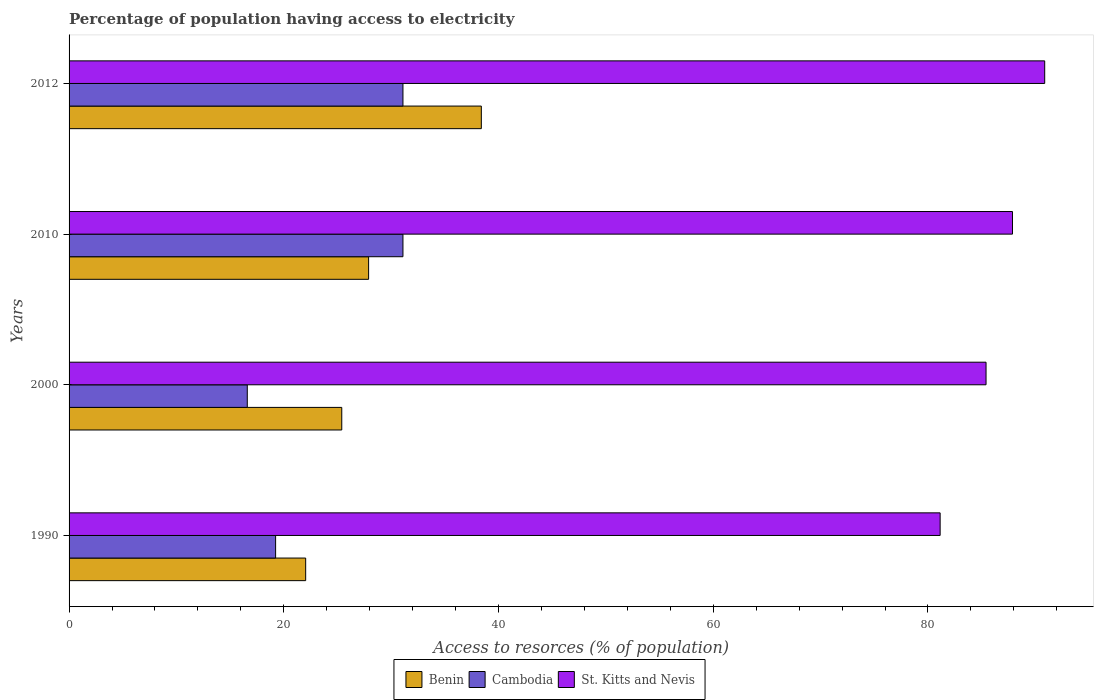How many different coloured bars are there?
Your answer should be very brief. 3. Are the number of bars per tick equal to the number of legend labels?
Give a very brief answer. Yes. Are the number of bars on each tick of the Y-axis equal?
Offer a terse response. Yes. How many bars are there on the 3rd tick from the top?
Make the answer very short. 3. How many bars are there on the 3rd tick from the bottom?
Make the answer very short. 3. In how many cases, is the number of bars for a given year not equal to the number of legend labels?
Offer a terse response. 0. What is the percentage of population having access to electricity in Benin in 2000?
Give a very brief answer. 25.4. Across all years, what is the maximum percentage of population having access to electricity in Cambodia?
Your answer should be very brief. 31.1. What is the total percentage of population having access to electricity in St. Kitts and Nevis in the graph?
Your answer should be compact. 345.3. What is the difference between the percentage of population having access to electricity in Cambodia in 1990 and that in 2000?
Ensure brevity in your answer.  2.64. What is the difference between the percentage of population having access to electricity in St. Kitts and Nevis in 2000 and the percentage of population having access to electricity in Cambodia in 2012?
Make the answer very short. 54.31. What is the average percentage of population having access to electricity in Cambodia per year?
Give a very brief answer. 24.51. In the year 2012, what is the difference between the percentage of population having access to electricity in St. Kitts and Nevis and percentage of population having access to electricity in Cambodia?
Your answer should be compact. 59.78. In how many years, is the percentage of population having access to electricity in St. Kitts and Nevis greater than 24 %?
Provide a succinct answer. 4. What is the ratio of the percentage of population having access to electricity in St. Kitts and Nevis in 2000 to that in 2012?
Make the answer very short. 0.94. Is the percentage of population having access to electricity in Benin in 2000 less than that in 2010?
Provide a short and direct response. Yes. What is the difference between the highest and the second highest percentage of population having access to electricity in St. Kitts and Nevis?
Provide a short and direct response. 3. What is the difference between the highest and the lowest percentage of population having access to electricity in St. Kitts and Nevis?
Your response must be concise. 9.74. Is the sum of the percentage of population having access to electricity in St. Kitts and Nevis in 1990 and 2012 greater than the maximum percentage of population having access to electricity in Cambodia across all years?
Provide a short and direct response. Yes. What does the 3rd bar from the top in 2010 represents?
Give a very brief answer. Benin. What does the 1st bar from the bottom in 1990 represents?
Offer a terse response. Benin. Is it the case that in every year, the sum of the percentage of population having access to electricity in Cambodia and percentage of population having access to electricity in Benin is greater than the percentage of population having access to electricity in St. Kitts and Nevis?
Give a very brief answer. No. What is the difference between two consecutive major ticks on the X-axis?
Provide a succinct answer. 20. Are the values on the major ticks of X-axis written in scientific E-notation?
Your answer should be very brief. No. How are the legend labels stacked?
Keep it short and to the point. Horizontal. What is the title of the graph?
Offer a very short reply. Percentage of population having access to electricity. What is the label or title of the X-axis?
Keep it short and to the point. Access to resorces (% of population). What is the Access to resorces (% of population) of Benin in 1990?
Provide a short and direct response. 22.04. What is the Access to resorces (% of population) in Cambodia in 1990?
Your response must be concise. 19.24. What is the Access to resorces (% of population) in St. Kitts and Nevis in 1990?
Provide a succinct answer. 81.14. What is the Access to resorces (% of population) in Benin in 2000?
Make the answer very short. 25.4. What is the Access to resorces (% of population) of Cambodia in 2000?
Your answer should be very brief. 16.6. What is the Access to resorces (% of population) of St. Kitts and Nevis in 2000?
Provide a short and direct response. 85.41. What is the Access to resorces (% of population) in Benin in 2010?
Offer a very short reply. 27.9. What is the Access to resorces (% of population) of Cambodia in 2010?
Your response must be concise. 31.1. What is the Access to resorces (% of population) of St. Kitts and Nevis in 2010?
Your response must be concise. 87.87. What is the Access to resorces (% of population) of Benin in 2012?
Ensure brevity in your answer.  38.4. What is the Access to resorces (% of population) of Cambodia in 2012?
Your answer should be compact. 31.1. What is the Access to resorces (% of population) of St. Kitts and Nevis in 2012?
Your answer should be very brief. 90.88. Across all years, what is the maximum Access to resorces (% of population) in Benin?
Ensure brevity in your answer.  38.4. Across all years, what is the maximum Access to resorces (% of population) in Cambodia?
Your response must be concise. 31.1. Across all years, what is the maximum Access to resorces (% of population) of St. Kitts and Nevis?
Give a very brief answer. 90.88. Across all years, what is the minimum Access to resorces (% of population) of Benin?
Give a very brief answer. 22.04. Across all years, what is the minimum Access to resorces (% of population) of Cambodia?
Offer a very short reply. 16.6. Across all years, what is the minimum Access to resorces (% of population) in St. Kitts and Nevis?
Offer a terse response. 81.14. What is the total Access to resorces (% of population) in Benin in the graph?
Give a very brief answer. 113.74. What is the total Access to resorces (% of population) of Cambodia in the graph?
Keep it short and to the point. 98.04. What is the total Access to resorces (% of population) of St. Kitts and Nevis in the graph?
Provide a succinct answer. 345.3. What is the difference between the Access to resorces (% of population) of Benin in 1990 and that in 2000?
Your answer should be very brief. -3.36. What is the difference between the Access to resorces (% of population) of Cambodia in 1990 and that in 2000?
Provide a short and direct response. 2.64. What is the difference between the Access to resorces (% of population) of St. Kitts and Nevis in 1990 and that in 2000?
Keep it short and to the point. -4.28. What is the difference between the Access to resorces (% of population) of Benin in 1990 and that in 2010?
Offer a very short reply. -5.86. What is the difference between the Access to resorces (% of population) in Cambodia in 1990 and that in 2010?
Your answer should be very brief. -11.86. What is the difference between the Access to resorces (% of population) of St. Kitts and Nevis in 1990 and that in 2010?
Your response must be concise. -6.74. What is the difference between the Access to resorces (% of population) of Benin in 1990 and that in 2012?
Keep it short and to the point. -16.36. What is the difference between the Access to resorces (% of population) of Cambodia in 1990 and that in 2012?
Make the answer very short. -11.86. What is the difference between the Access to resorces (% of population) of St. Kitts and Nevis in 1990 and that in 2012?
Make the answer very short. -9.74. What is the difference between the Access to resorces (% of population) in St. Kitts and Nevis in 2000 and that in 2010?
Offer a terse response. -2.46. What is the difference between the Access to resorces (% of population) in St. Kitts and Nevis in 2000 and that in 2012?
Offer a terse response. -5.46. What is the difference between the Access to resorces (% of population) of Benin in 2010 and that in 2012?
Make the answer very short. -10.5. What is the difference between the Access to resorces (% of population) in Cambodia in 2010 and that in 2012?
Offer a terse response. 0. What is the difference between the Access to resorces (% of population) in St. Kitts and Nevis in 2010 and that in 2012?
Make the answer very short. -3. What is the difference between the Access to resorces (% of population) of Benin in 1990 and the Access to resorces (% of population) of Cambodia in 2000?
Make the answer very short. 5.44. What is the difference between the Access to resorces (% of population) of Benin in 1990 and the Access to resorces (% of population) of St. Kitts and Nevis in 2000?
Provide a succinct answer. -63.37. What is the difference between the Access to resorces (% of population) in Cambodia in 1990 and the Access to resorces (% of population) in St. Kitts and Nevis in 2000?
Give a very brief answer. -66.17. What is the difference between the Access to resorces (% of population) of Benin in 1990 and the Access to resorces (% of population) of Cambodia in 2010?
Give a very brief answer. -9.06. What is the difference between the Access to resorces (% of population) of Benin in 1990 and the Access to resorces (% of population) of St. Kitts and Nevis in 2010?
Your answer should be compact. -65.84. What is the difference between the Access to resorces (% of population) in Cambodia in 1990 and the Access to resorces (% of population) in St. Kitts and Nevis in 2010?
Give a very brief answer. -68.64. What is the difference between the Access to resorces (% of population) in Benin in 1990 and the Access to resorces (% of population) in Cambodia in 2012?
Offer a terse response. -9.06. What is the difference between the Access to resorces (% of population) of Benin in 1990 and the Access to resorces (% of population) of St. Kitts and Nevis in 2012?
Give a very brief answer. -68.84. What is the difference between the Access to resorces (% of population) in Cambodia in 1990 and the Access to resorces (% of population) in St. Kitts and Nevis in 2012?
Keep it short and to the point. -71.64. What is the difference between the Access to resorces (% of population) of Benin in 2000 and the Access to resorces (% of population) of St. Kitts and Nevis in 2010?
Your response must be concise. -62.47. What is the difference between the Access to resorces (% of population) of Cambodia in 2000 and the Access to resorces (% of population) of St. Kitts and Nevis in 2010?
Make the answer very short. -71.27. What is the difference between the Access to resorces (% of population) of Benin in 2000 and the Access to resorces (% of population) of Cambodia in 2012?
Your answer should be compact. -5.7. What is the difference between the Access to resorces (% of population) of Benin in 2000 and the Access to resorces (% of population) of St. Kitts and Nevis in 2012?
Give a very brief answer. -65.48. What is the difference between the Access to resorces (% of population) in Cambodia in 2000 and the Access to resorces (% of population) in St. Kitts and Nevis in 2012?
Your response must be concise. -74.28. What is the difference between the Access to resorces (% of population) of Benin in 2010 and the Access to resorces (% of population) of Cambodia in 2012?
Give a very brief answer. -3.2. What is the difference between the Access to resorces (% of population) of Benin in 2010 and the Access to resorces (% of population) of St. Kitts and Nevis in 2012?
Ensure brevity in your answer.  -62.98. What is the difference between the Access to resorces (% of population) in Cambodia in 2010 and the Access to resorces (% of population) in St. Kitts and Nevis in 2012?
Give a very brief answer. -59.78. What is the average Access to resorces (% of population) of Benin per year?
Provide a succinct answer. 28.43. What is the average Access to resorces (% of population) in Cambodia per year?
Make the answer very short. 24.51. What is the average Access to resorces (% of population) in St. Kitts and Nevis per year?
Your response must be concise. 86.32. In the year 1990, what is the difference between the Access to resorces (% of population) in Benin and Access to resorces (% of population) in Cambodia?
Ensure brevity in your answer.  2.8. In the year 1990, what is the difference between the Access to resorces (% of population) of Benin and Access to resorces (% of population) of St. Kitts and Nevis?
Ensure brevity in your answer.  -59.1. In the year 1990, what is the difference between the Access to resorces (% of population) of Cambodia and Access to resorces (% of population) of St. Kitts and Nevis?
Ensure brevity in your answer.  -61.9. In the year 2000, what is the difference between the Access to resorces (% of population) of Benin and Access to resorces (% of population) of Cambodia?
Give a very brief answer. 8.8. In the year 2000, what is the difference between the Access to resorces (% of population) of Benin and Access to resorces (% of population) of St. Kitts and Nevis?
Make the answer very short. -60.01. In the year 2000, what is the difference between the Access to resorces (% of population) in Cambodia and Access to resorces (% of population) in St. Kitts and Nevis?
Offer a very short reply. -68.81. In the year 2010, what is the difference between the Access to resorces (% of population) in Benin and Access to resorces (% of population) in Cambodia?
Ensure brevity in your answer.  -3.2. In the year 2010, what is the difference between the Access to resorces (% of population) of Benin and Access to resorces (% of population) of St. Kitts and Nevis?
Your response must be concise. -59.97. In the year 2010, what is the difference between the Access to resorces (% of population) in Cambodia and Access to resorces (% of population) in St. Kitts and Nevis?
Your response must be concise. -56.77. In the year 2012, what is the difference between the Access to resorces (% of population) of Benin and Access to resorces (% of population) of St. Kitts and Nevis?
Your answer should be very brief. -52.48. In the year 2012, what is the difference between the Access to resorces (% of population) of Cambodia and Access to resorces (% of population) of St. Kitts and Nevis?
Make the answer very short. -59.78. What is the ratio of the Access to resorces (% of population) in Benin in 1990 to that in 2000?
Your response must be concise. 0.87. What is the ratio of the Access to resorces (% of population) in Cambodia in 1990 to that in 2000?
Offer a terse response. 1.16. What is the ratio of the Access to resorces (% of population) of St. Kitts and Nevis in 1990 to that in 2000?
Your answer should be very brief. 0.95. What is the ratio of the Access to resorces (% of population) of Benin in 1990 to that in 2010?
Keep it short and to the point. 0.79. What is the ratio of the Access to resorces (% of population) of Cambodia in 1990 to that in 2010?
Offer a terse response. 0.62. What is the ratio of the Access to resorces (% of population) in St. Kitts and Nevis in 1990 to that in 2010?
Make the answer very short. 0.92. What is the ratio of the Access to resorces (% of population) of Benin in 1990 to that in 2012?
Offer a terse response. 0.57. What is the ratio of the Access to resorces (% of population) in Cambodia in 1990 to that in 2012?
Your answer should be very brief. 0.62. What is the ratio of the Access to resorces (% of population) in St. Kitts and Nevis in 1990 to that in 2012?
Your answer should be compact. 0.89. What is the ratio of the Access to resorces (% of population) in Benin in 2000 to that in 2010?
Your answer should be very brief. 0.91. What is the ratio of the Access to resorces (% of population) of Cambodia in 2000 to that in 2010?
Keep it short and to the point. 0.53. What is the ratio of the Access to resorces (% of population) in St. Kitts and Nevis in 2000 to that in 2010?
Offer a terse response. 0.97. What is the ratio of the Access to resorces (% of population) in Benin in 2000 to that in 2012?
Offer a very short reply. 0.66. What is the ratio of the Access to resorces (% of population) in Cambodia in 2000 to that in 2012?
Your answer should be compact. 0.53. What is the ratio of the Access to resorces (% of population) in St. Kitts and Nevis in 2000 to that in 2012?
Provide a short and direct response. 0.94. What is the ratio of the Access to resorces (% of population) in Benin in 2010 to that in 2012?
Provide a short and direct response. 0.73. What is the ratio of the Access to resorces (% of population) in Cambodia in 2010 to that in 2012?
Offer a very short reply. 1. What is the ratio of the Access to resorces (% of population) in St. Kitts and Nevis in 2010 to that in 2012?
Offer a very short reply. 0.97. What is the difference between the highest and the second highest Access to resorces (% of population) in Benin?
Offer a terse response. 10.5. What is the difference between the highest and the second highest Access to resorces (% of population) in St. Kitts and Nevis?
Ensure brevity in your answer.  3. What is the difference between the highest and the lowest Access to resorces (% of population) of Benin?
Your answer should be compact. 16.36. What is the difference between the highest and the lowest Access to resorces (% of population) in St. Kitts and Nevis?
Provide a short and direct response. 9.74. 